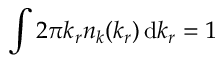Convert formula to latex. <formula><loc_0><loc_0><loc_500><loc_500>\int 2 \pi k _ { r } n _ { k } ( k _ { r } ) \, d k _ { r } = 1</formula> 